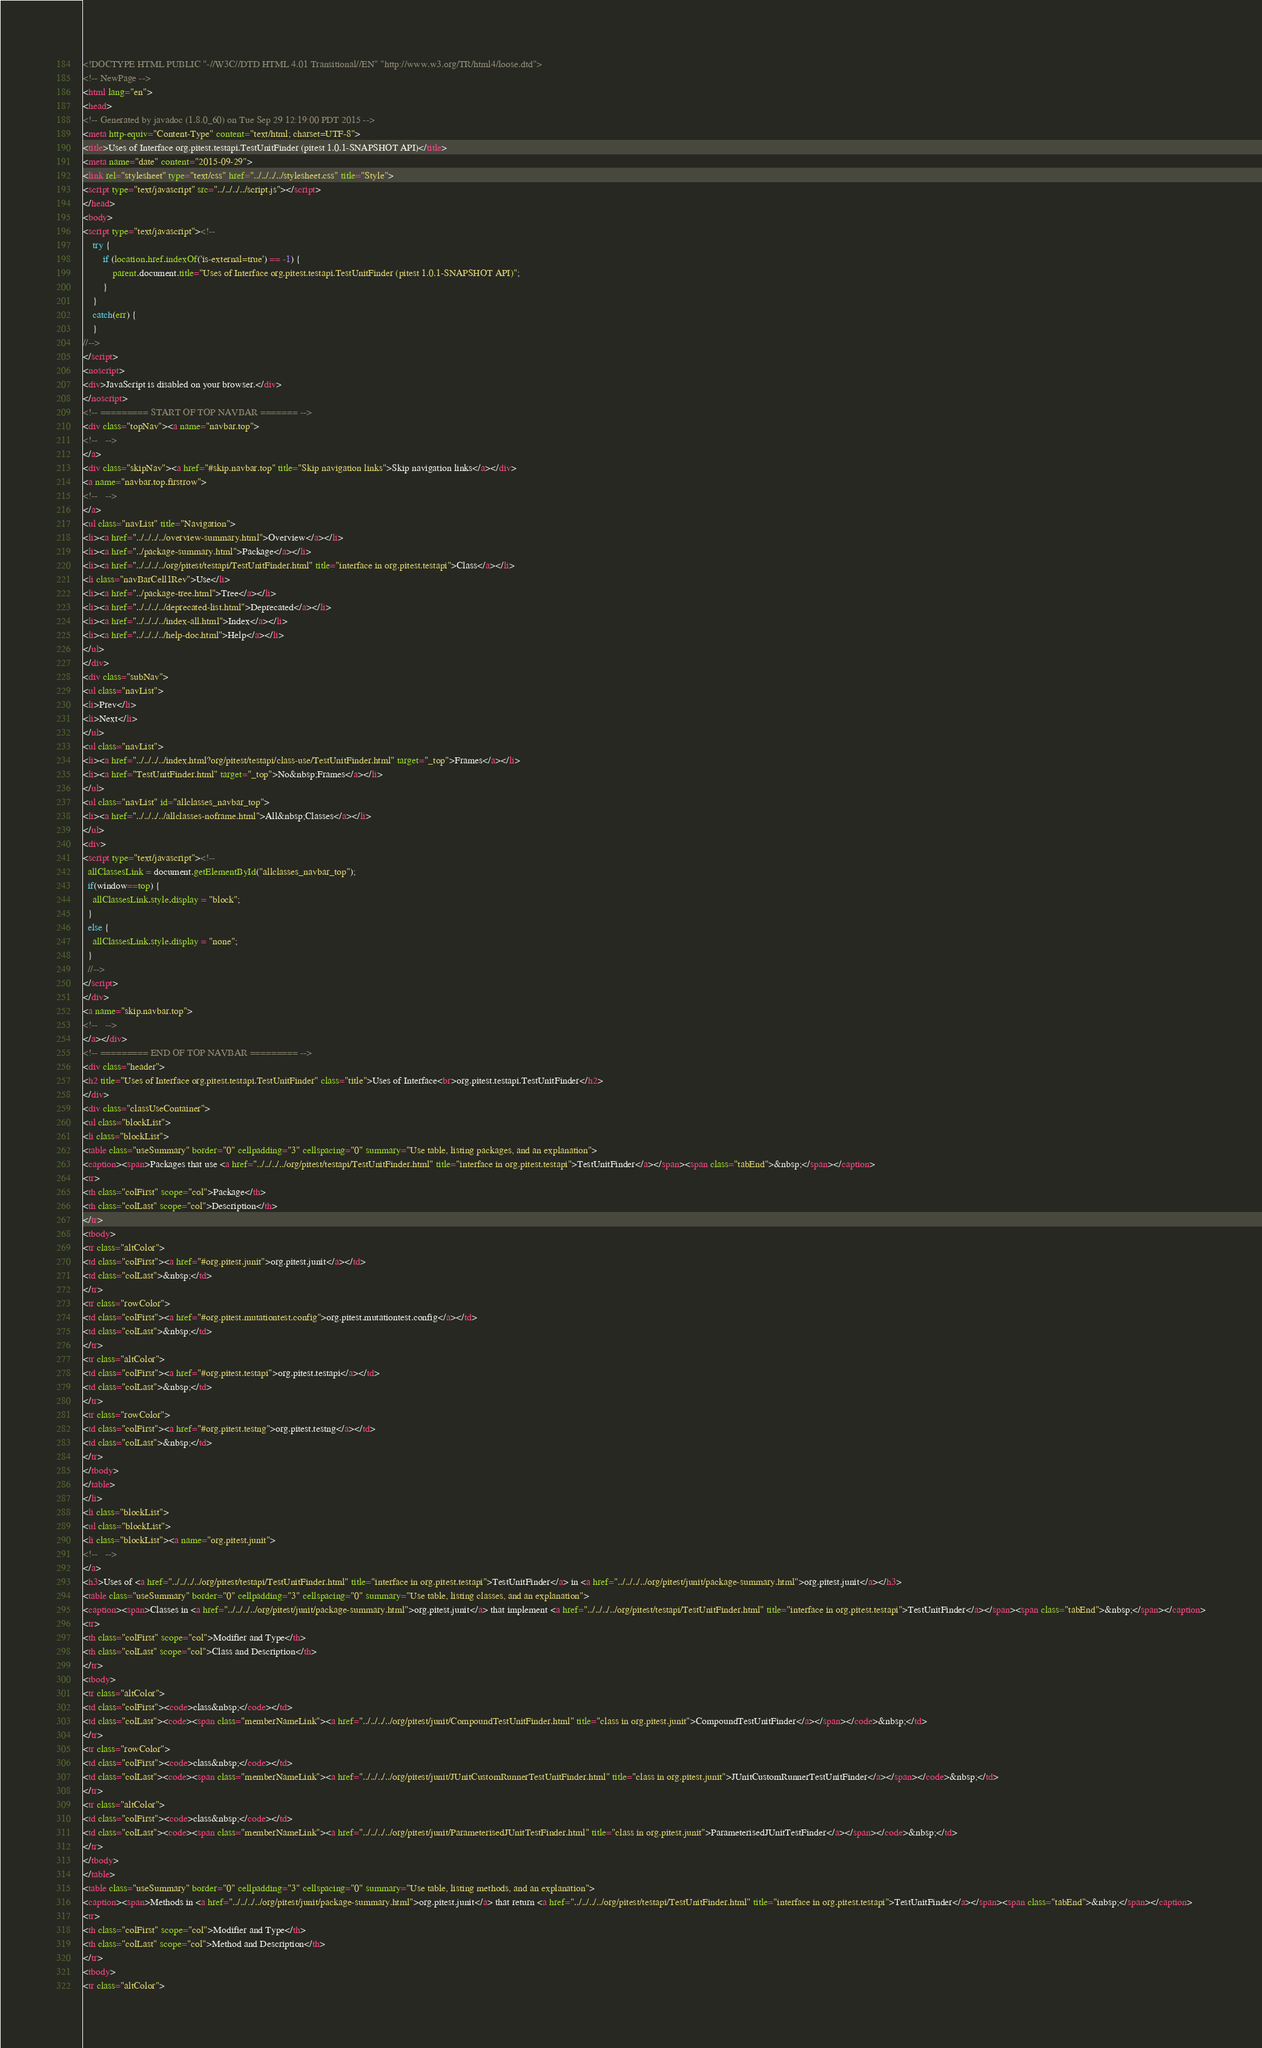Convert code to text. <code><loc_0><loc_0><loc_500><loc_500><_HTML_><!DOCTYPE HTML PUBLIC "-//W3C//DTD HTML 4.01 Transitional//EN" "http://www.w3.org/TR/html4/loose.dtd">
<!-- NewPage -->
<html lang="en">
<head>
<!-- Generated by javadoc (1.8.0_60) on Tue Sep 29 12:19:00 PDT 2015 -->
<meta http-equiv="Content-Type" content="text/html; charset=UTF-8">
<title>Uses of Interface org.pitest.testapi.TestUnitFinder (pitest 1.0.1-SNAPSHOT API)</title>
<meta name="date" content="2015-09-29">
<link rel="stylesheet" type="text/css" href="../../../../stylesheet.css" title="Style">
<script type="text/javascript" src="../../../../script.js"></script>
</head>
<body>
<script type="text/javascript"><!--
    try {
        if (location.href.indexOf('is-external=true') == -1) {
            parent.document.title="Uses of Interface org.pitest.testapi.TestUnitFinder (pitest 1.0.1-SNAPSHOT API)";
        }
    }
    catch(err) {
    }
//-->
</script>
<noscript>
<div>JavaScript is disabled on your browser.</div>
</noscript>
<!-- ========= START OF TOP NAVBAR ======= -->
<div class="topNav"><a name="navbar.top">
<!--   -->
</a>
<div class="skipNav"><a href="#skip.navbar.top" title="Skip navigation links">Skip navigation links</a></div>
<a name="navbar.top.firstrow">
<!--   -->
</a>
<ul class="navList" title="Navigation">
<li><a href="../../../../overview-summary.html">Overview</a></li>
<li><a href="../package-summary.html">Package</a></li>
<li><a href="../../../../org/pitest/testapi/TestUnitFinder.html" title="interface in org.pitest.testapi">Class</a></li>
<li class="navBarCell1Rev">Use</li>
<li><a href="../package-tree.html">Tree</a></li>
<li><a href="../../../../deprecated-list.html">Deprecated</a></li>
<li><a href="../../../../index-all.html">Index</a></li>
<li><a href="../../../../help-doc.html">Help</a></li>
</ul>
</div>
<div class="subNav">
<ul class="navList">
<li>Prev</li>
<li>Next</li>
</ul>
<ul class="navList">
<li><a href="../../../../index.html?org/pitest/testapi/class-use/TestUnitFinder.html" target="_top">Frames</a></li>
<li><a href="TestUnitFinder.html" target="_top">No&nbsp;Frames</a></li>
</ul>
<ul class="navList" id="allclasses_navbar_top">
<li><a href="../../../../allclasses-noframe.html">All&nbsp;Classes</a></li>
</ul>
<div>
<script type="text/javascript"><!--
  allClassesLink = document.getElementById("allclasses_navbar_top");
  if(window==top) {
    allClassesLink.style.display = "block";
  }
  else {
    allClassesLink.style.display = "none";
  }
  //-->
</script>
</div>
<a name="skip.navbar.top">
<!--   -->
</a></div>
<!-- ========= END OF TOP NAVBAR ========= -->
<div class="header">
<h2 title="Uses of Interface org.pitest.testapi.TestUnitFinder" class="title">Uses of Interface<br>org.pitest.testapi.TestUnitFinder</h2>
</div>
<div class="classUseContainer">
<ul class="blockList">
<li class="blockList">
<table class="useSummary" border="0" cellpadding="3" cellspacing="0" summary="Use table, listing packages, and an explanation">
<caption><span>Packages that use <a href="../../../../org/pitest/testapi/TestUnitFinder.html" title="interface in org.pitest.testapi">TestUnitFinder</a></span><span class="tabEnd">&nbsp;</span></caption>
<tr>
<th class="colFirst" scope="col">Package</th>
<th class="colLast" scope="col">Description</th>
</tr>
<tbody>
<tr class="altColor">
<td class="colFirst"><a href="#org.pitest.junit">org.pitest.junit</a></td>
<td class="colLast">&nbsp;</td>
</tr>
<tr class="rowColor">
<td class="colFirst"><a href="#org.pitest.mutationtest.config">org.pitest.mutationtest.config</a></td>
<td class="colLast">&nbsp;</td>
</tr>
<tr class="altColor">
<td class="colFirst"><a href="#org.pitest.testapi">org.pitest.testapi</a></td>
<td class="colLast">&nbsp;</td>
</tr>
<tr class="rowColor">
<td class="colFirst"><a href="#org.pitest.testng">org.pitest.testng</a></td>
<td class="colLast">&nbsp;</td>
</tr>
</tbody>
</table>
</li>
<li class="blockList">
<ul class="blockList">
<li class="blockList"><a name="org.pitest.junit">
<!--   -->
</a>
<h3>Uses of <a href="../../../../org/pitest/testapi/TestUnitFinder.html" title="interface in org.pitest.testapi">TestUnitFinder</a> in <a href="../../../../org/pitest/junit/package-summary.html">org.pitest.junit</a></h3>
<table class="useSummary" border="0" cellpadding="3" cellspacing="0" summary="Use table, listing classes, and an explanation">
<caption><span>Classes in <a href="../../../../org/pitest/junit/package-summary.html">org.pitest.junit</a> that implement <a href="../../../../org/pitest/testapi/TestUnitFinder.html" title="interface in org.pitest.testapi">TestUnitFinder</a></span><span class="tabEnd">&nbsp;</span></caption>
<tr>
<th class="colFirst" scope="col">Modifier and Type</th>
<th class="colLast" scope="col">Class and Description</th>
</tr>
<tbody>
<tr class="altColor">
<td class="colFirst"><code>class&nbsp;</code></td>
<td class="colLast"><code><span class="memberNameLink"><a href="../../../../org/pitest/junit/CompoundTestUnitFinder.html" title="class in org.pitest.junit">CompoundTestUnitFinder</a></span></code>&nbsp;</td>
</tr>
<tr class="rowColor">
<td class="colFirst"><code>class&nbsp;</code></td>
<td class="colLast"><code><span class="memberNameLink"><a href="../../../../org/pitest/junit/JUnitCustomRunnerTestUnitFinder.html" title="class in org.pitest.junit">JUnitCustomRunnerTestUnitFinder</a></span></code>&nbsp;</td>
</tr>
<tr class="altColor">
<td class="colFirst"><code>class&nbsp;</code></td>
<td class="colLast"><code><span class="memberNameLink"><a href="../../../../org/pitest/junit/ParameterisedJUnitTestFinder.html" title="class in org.pitest.junit">ParameterisedJUnitTestFinder</a></span></code>&nbsp;</td>
</tr>
</tbody>
</table>
<table class="useSummary" border="0" cellpadding="3" cellspacing="0" summary="Use table, listing methods, and an explanation">
<caption><span>Methods in <a href="../../../../org/pitest/junit/package-summary.html">org.pitest.junit</a> that return <a href="../../../../org/pitest/testapi/TestUnitFinder.html" title="interface in org.pitest.testapi">TestUnitFinder</a></span><span class="tabEnd">&nbsp;</span></caption>
<tr>
<th class="colFirst" scope="col">Modifier and Type</th>
<th class="colLast" scope="col">Method and Description</th>
</tr>
<tbody>
<tr class="altColor"></code> 